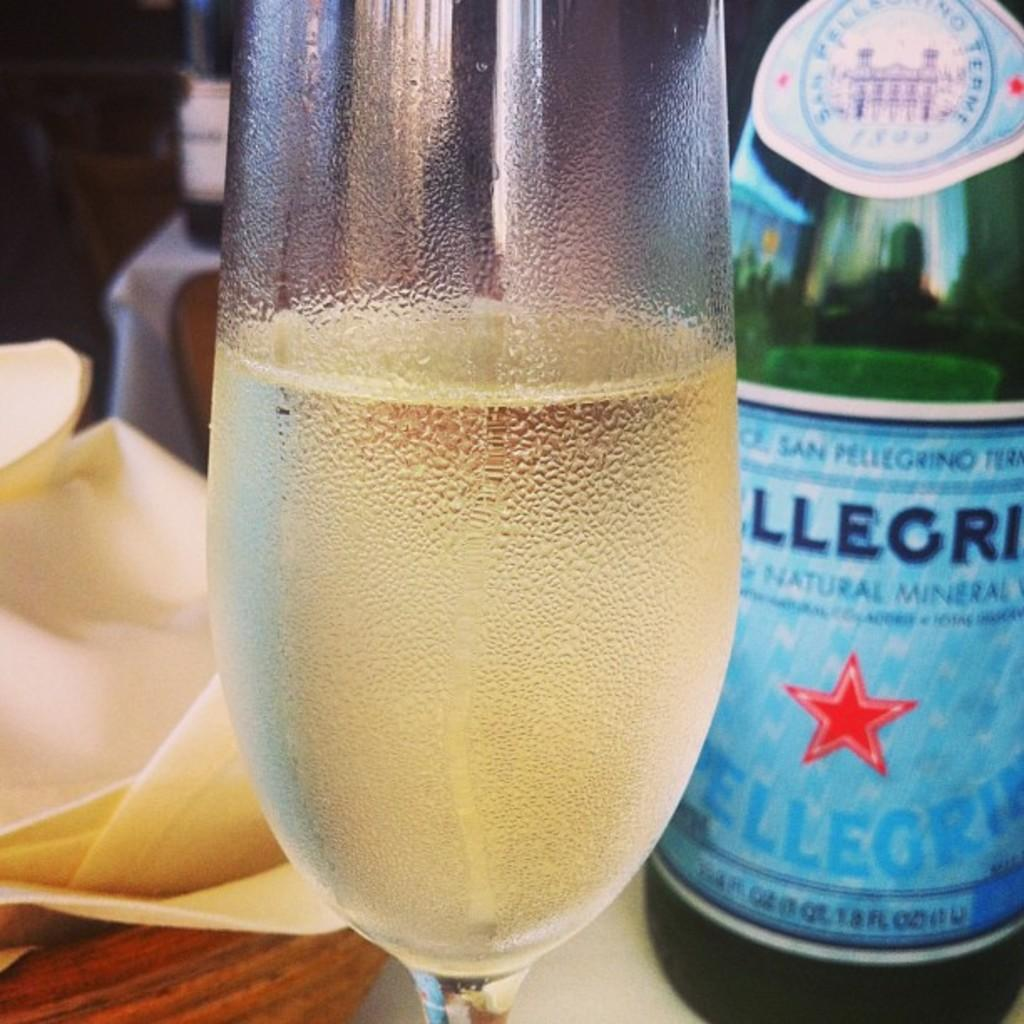<image>
Describe the image concisely. A bottle of San Pelligrino behind a glass. 